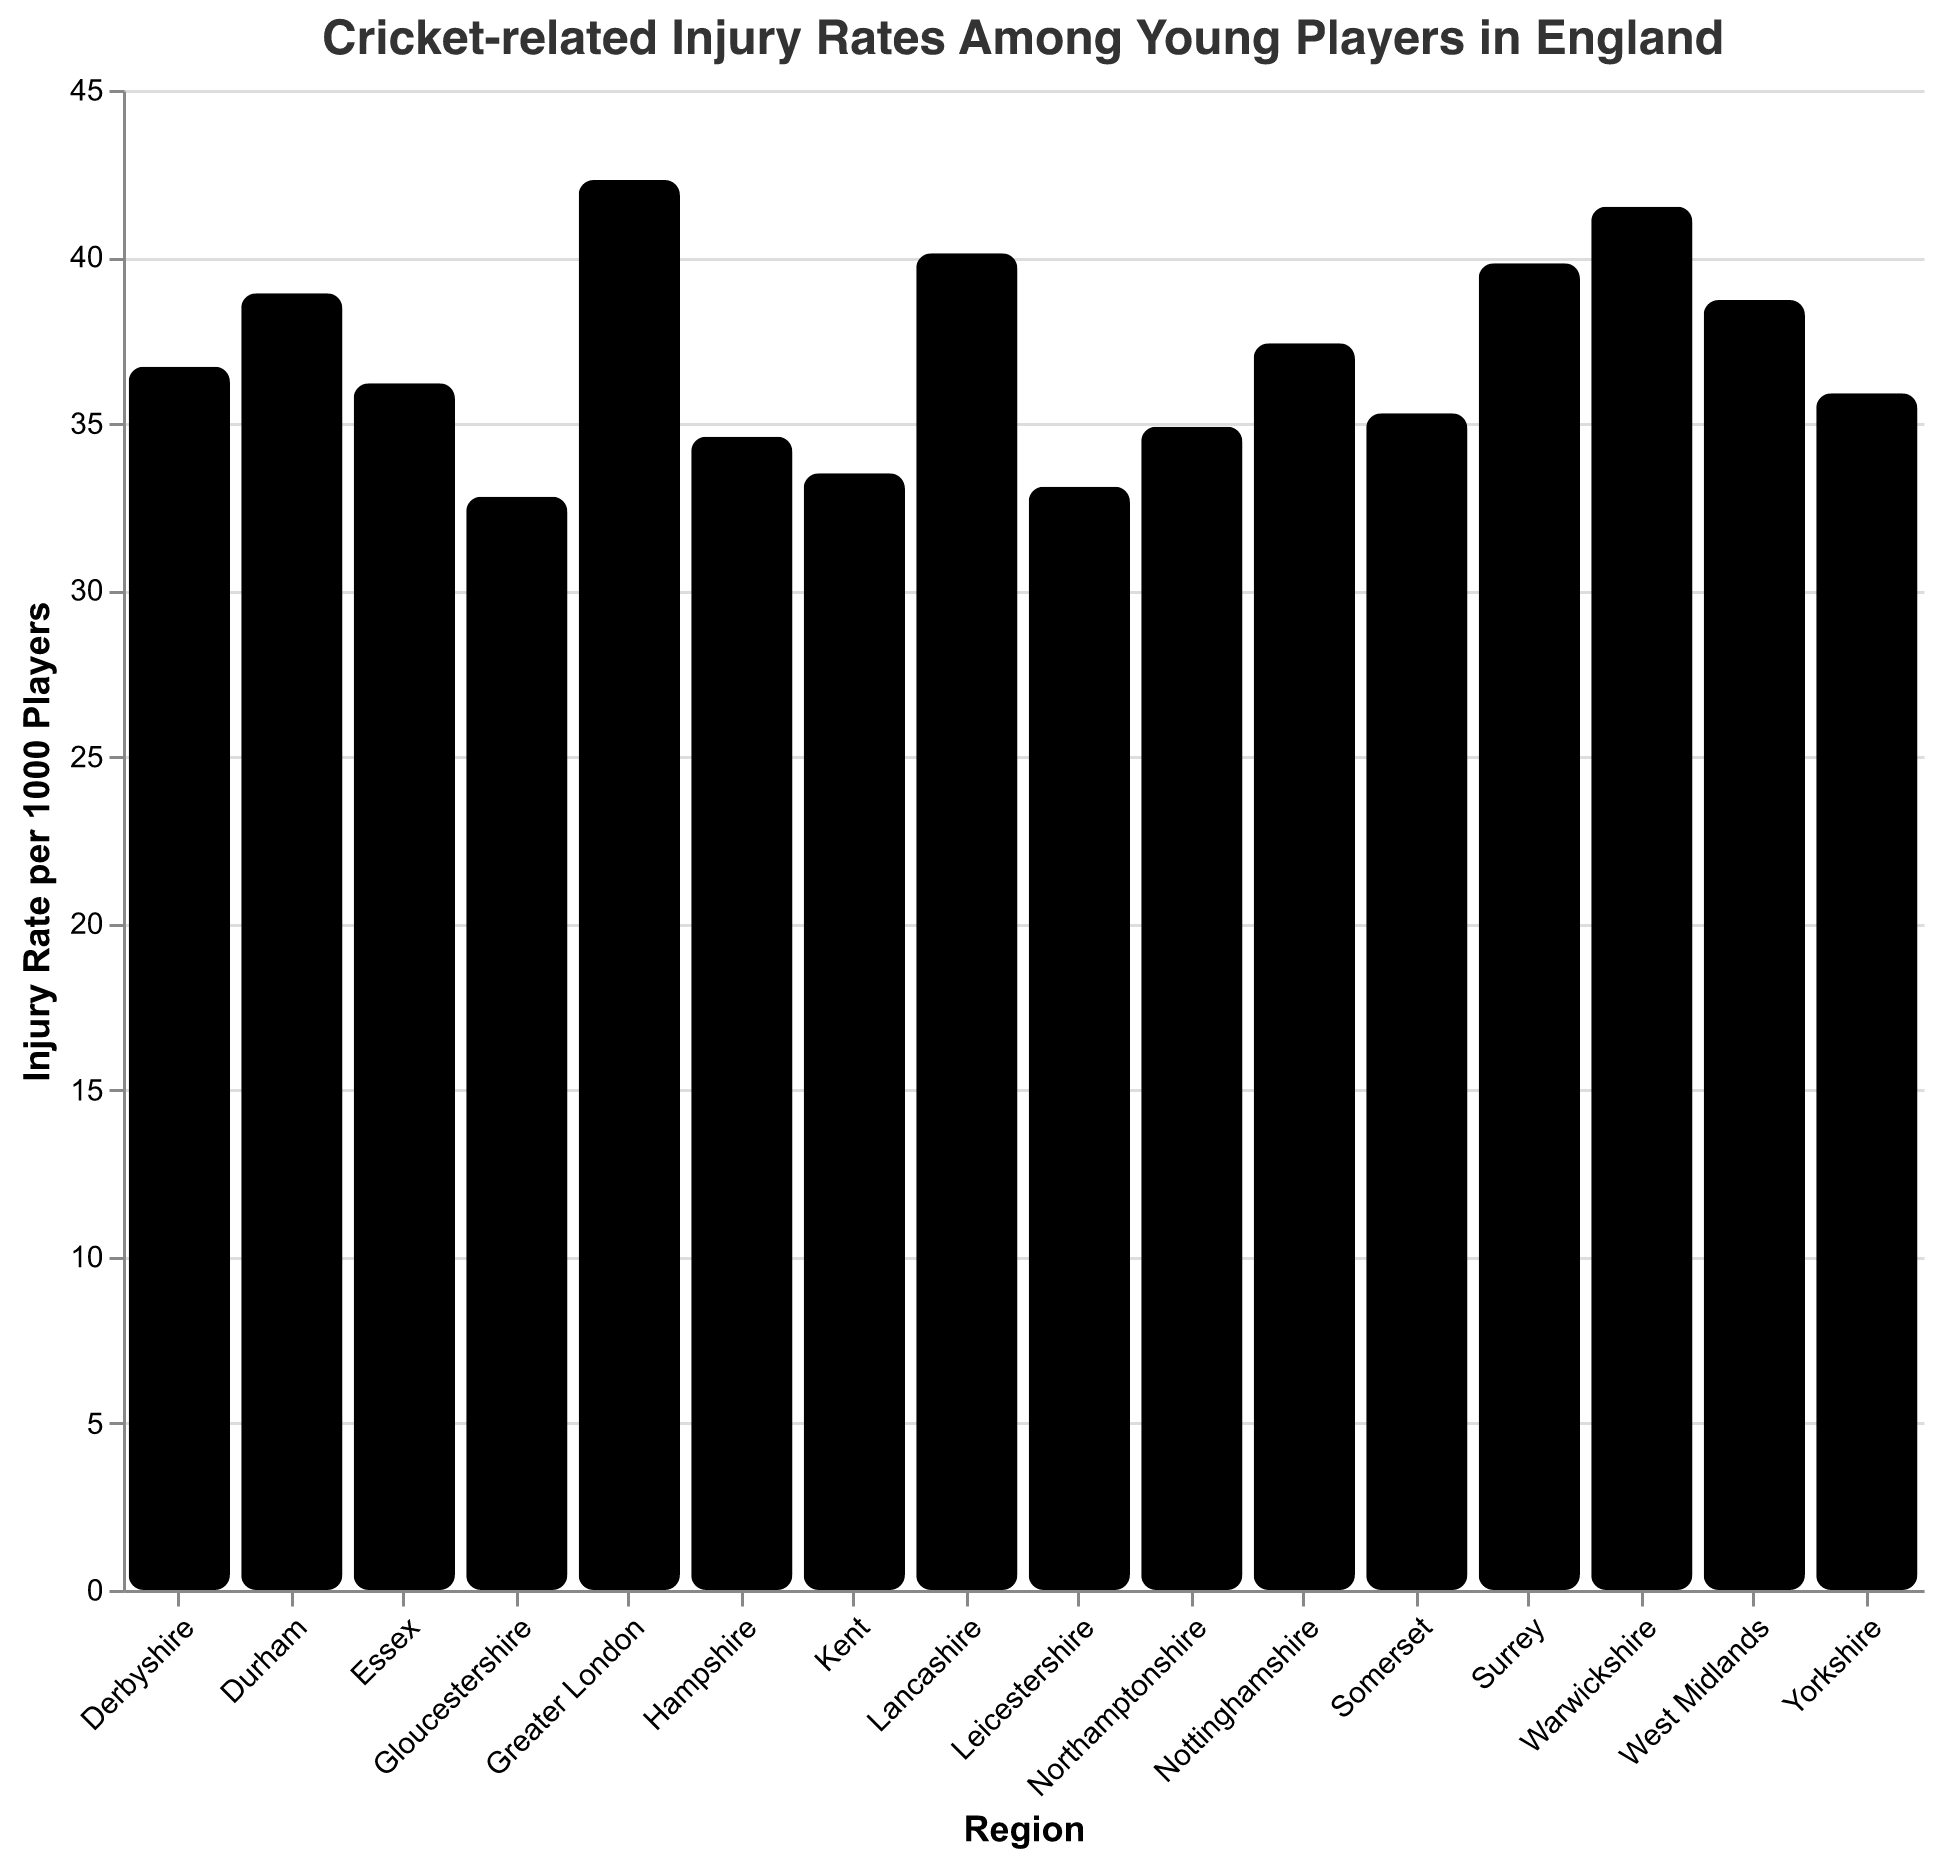Which region has the highest injury rate? By looking at the bar heights and tooltip values, Greater London has the highest injury rate at 42.3 injuries per 1000 players.
Answer: Greater London What is the title of the figure? The title is displayed prominently at the top of the figure and states, "Cricket-related Injury Rates Among Young Players in England."
Answer: Cricket-related Injury Rates Among Young Players in England Which region has the lowest injury rate? By observing the shortest bar and tooltip values, Gloucestershire has the lowest injury rate at 32.8 injuries per 1000 players.
Answer: Gloucestershire How many regions have an injury rate higher than 40? By examining the bar lengths and their corresponding tooltip values, there are 3 regions: Greater London, Lancashire, and Warwickshire.
Answer: 3 What's the average injury rate across all the regions? Sum all the injury rates and divide by the number of regions. (42.3 + 38.7 + 35.9 + 40.1 + 33.5 + 36.2 + 39.8 + 34.6 + 37.4 + 41.5 + 32.8 + 35.3 + 38.9 + 36.7 + 33.1 + 34.9) / 16 = 37.1
Answer: 37.1 How does the injury rate in West Midlands compare with that in Nottinghamshire? West Midlands has an injury rate of 38.7, while Nottinghamshire has 37.4. Comparing these values, West Midlands has a higher rate than Nottinghamshire.
Answer: West Midlands > Nottinghamshire By how much does the injury rate in Surrey exceed that in Essex? Surrey has an injury rate of 39.8, and Essex has 36.2. The difference is 39.8 - 36.2 = 3.6 injuries per 1000 players.
Answer: 3.6 Identify the regions with injury rates between 35 and 37. By filtering the values, we see that Yorkshire (35.9), Essex (36.2), Derbyshire (36.7), and Northamptonshire (34.9) fall within this range.
Answer: Yorkshire, Essex, Derbyshire, Northamptonshire What's the difference in injury rates between the highest and lowest regions? The highest is Greater London at 42.3, and the lowest is Gloucestershire at 32.8. The difference is 42.3 - 32.8 = 9.5 injuries per 1000 players.
Answer: 9.5 What regions have nearly equal injury rates? Observing the bars and tooltip values, Surrey (39.8) and Warwickshire (41.5) have closely similar injury rates, as do Derbyshire (36.7) and Essex (36.2).
Answer: Surrey and Warwickshire; Derbyshire and Essex 